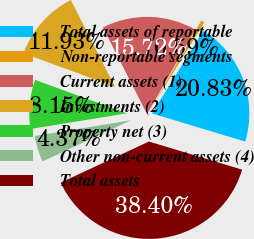<chart> <loc_0><loc_0><loc_500><loc_500><pie_chart><fcel>Total assets of reportable<fcel>Non-reportable segments<fcel>Current assets (1)<fcel>Investments (2)<fcel>Property net (3)<fcel>Other non-current assets (4)<fcel>Total assets<nl><fcel>20.83%<fcel>0.59%<fcel>15.72%<fcel>11.93%<fcel>8.15%<fcel>4.37%<fcel>38.4%<nl></chart> 